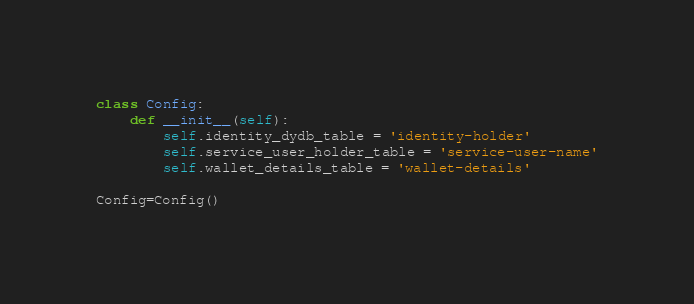Convert code to text. <code><loc_0><loc_0><loc_500><loc_500><_Python_>class Config:
    def __init__(self):
        self.identity_dydb_table = 'identity-holder'
        self.service_user_holder_table = 'service-user-name'
        self.wallet_details_table = 'wallet-details'

Config=Config()</code> 